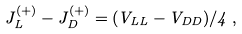Convert formula to latex. <formula><loc_0><loc_0><loc_500><loc_500>J _ { L } ^ { ( + ) } - J _ { D } ^ { ( + ) } = ( V _ { L L } - V _ { D D } ) / 4 \, ,</formula> 